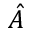Convert formula to latex. <formula><loc_0><loc_0><loc_500><loc_500>\hat { A }</formula> 